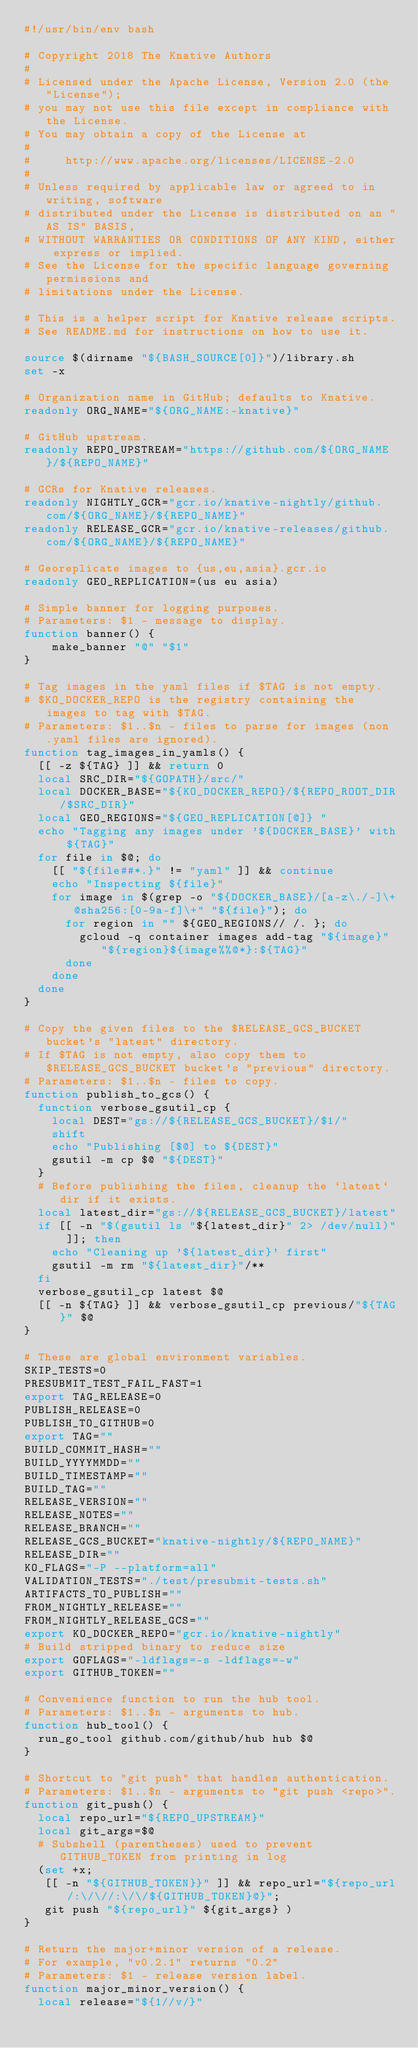<code> <loc_0><loc_0><loc_500><loc_500><_Bash_>#!/usr/bin/env bash

# Copyright 2018 The Knative Authors
#
# Licensed under the Apache License, Version 2.0 (the "License");
# you may not use this file except in compliance with the License.
# You may obtain a copy of the License at
#
#     http://www.apache.org/licenses/LICENSE-2.0
#
# Unless required by applicable law or agreed to in writing, software
# distributed under the License is distributed on an "AS IS" BASIS,
# WITHOUT WARRANTIES OR CONDITIONS OF ANY KIND, either express or implied.
# See the License for the specific language governing permissions and
# limitations under the License.

# This is a helper script for Knative release scripts.
# See README.md for instructions on how to use it.

source $(dirname "${BASH_SOURCE[0]}")/library.sh
set -x

# Organization name in GitHub; defaults to Knative.
readonly ORG_NAME="${ORG_NAME:-knative}"

# GitHub upstream.
readonly REPO_UPSTREAM="https://github.com/${ORG_NAME}/${REPO_NAME}"

# GCRs for Knative releases.
readonly NIGHTLY_GCR="gcr.io/knative-nightly/github.com/${ORG_NAME}/${REPO_NAME}"
readonly RELEASE_GCR="gcr.io/knative-releases/github.com/${ORG_NAME}/${REPO_NAME}"

# Georeplicate images to {us,eu,asia}.gcr.io
readonly GEO_REPLICATION=(us eu asia)

# Simple banner for logging purposes.
# Parameters: $1 - message to display.
function banner() {
    make_banner "@" "$1"
}

# Tag images in the yaml files if $TAG is not empty.
# $KO_DOCKER_REPO is the registry containing the images to tag with $TAG.
# Parameters: $1..$n - files to parse for images (non .yaml files are ignored).
function tag_images_in_yamls() {
  [[ -z ${TAG} ]] && return 0
  local SRC_DIR="${GOPATH}/src/"
  local DOCKER_BASE="${KO_DOCKER_REPO}/${REPO_ROOT_DIR/$SRC_DIR}"
  local GEO_REGIONS="${GEO_REPLICATION[@]} "
  echo "Tagging any images under '${DOCKER_BASE}' with ${TAG}"
  for file in $@; do
    [[ "${file##*.}" != "yaml" ]] && continue
    echo "Inspecting ${file}"
    for image in $(grep -o "${DOCKER_BASE}/[a-z\./-]\+@sha256:[0-9a-f]\+" "${file}"); do
      for region in "" ${GEO_REGIONS// /. }; do
        gcloud -q container images add-tag "${image}" "${region}${image%%@*}:${TAG}"
      done
    done
  done
}

# Copy the given files to the $RELEASE_GCS_BUCKET bucket's "latest" directory.
# If $TAG is not empty, also copy them to $RELEASE_GCS_BUCKET bucket's "previous" directory.
# Parameters: $1..$n - files to copy.
function publish_to_gcs() {
  function verbose_gsutil_cp {
    local DEST="gs://${RELEASE_GCS_BUCKET}/$1/"
    shift
    echo "Publishing [$@] to ${DEST}"
    gsutil -m cp $@ "${DEST}"
  }
  # Before publishing the files, cleanup the `latest` dir if it exists.
  local latest_dir="gs://${RELEASE_GCS_BUCKET}/latest"
  if [[ -n "$(gsutil ls "${latest_dir}" 2> /dev/null)" ]]; then
    echo "Cleaning up '${latest_dir}' first"
    gsutil -m rm "${latest_dir}"/**
  fi
  verbose_gsutil_cp latest $@
  [[ -n ${TAG} ]] && verbose_gsutil_cp previous/"${TAG}" $@
}

# These are global environment variables.
SKIP_TESTS=0
PRESUBMIT_TEST_FAIL_FAST=1
export TAG_RELEASE=0
PUBLISH_RELEASE=0
PUBLISH_TO_GITHUB=0
export TAG=""
BUILD_COMMIT_HASH=""
BUILD_YYYYMMDD=""
BUILD_TIMESTAMP=""
BUILD_TAG=""
RELEASE_VERSION=""
RELEASE_NOTES=""
RELEASE_BRANCH=""
RELEASE_GCS_BUCKET="knative-nightly/${REPO_NAME}"
RELEASE_DIR=""
KO_FLAGS="-P --platform=all"
VALIDATION_TESTS="./test/presubmit-tests.sh"
ARTIFACTS_TO_PUBLISH=""
FROM_NIGHTLY_RELEASE=""
FROM_NIGHTLY_RELEASE_GCS=""
export KO_DOCKER_REPO="gcr.io/knative-nightly"
# Build stripped binary to reduce size
export GOFLAGS="-ldflags=-s -ldflags=-w"
export GITHUB_TOKEN=""

# Convenience function to run the hub tool.
# Parameters: $1..$n - arguments to hub.
function hub_tool() {
  run_go_tool github.com/github/hub hub $@
}

# Shortcut to "git push" that handles authentication.
# Parameters: $1..$n - arguments to "git push <repo>".
function git_push() {
  local repo_url="${REPO_UPSTREAM}"
  local git_args=$@
  # Subshell (parentheses) used to prevent GITHUB_TOKEN from printing in log
  (set +x;
   [[ -n "${GITHUB_TOKEN}}" ]] && repo_url="${repo_url/:\/\//:\/\/${GITHUB_TOKEN}@}";
   git push "${repo_url}" ${git_args} )
}

# Return the major+minor version of a release.
# For example, "v0.2.1" returns "0.2"
# Parameters: $1 - release version label.
function major_minor_version() {
  local release="${1//v/}"</code> 